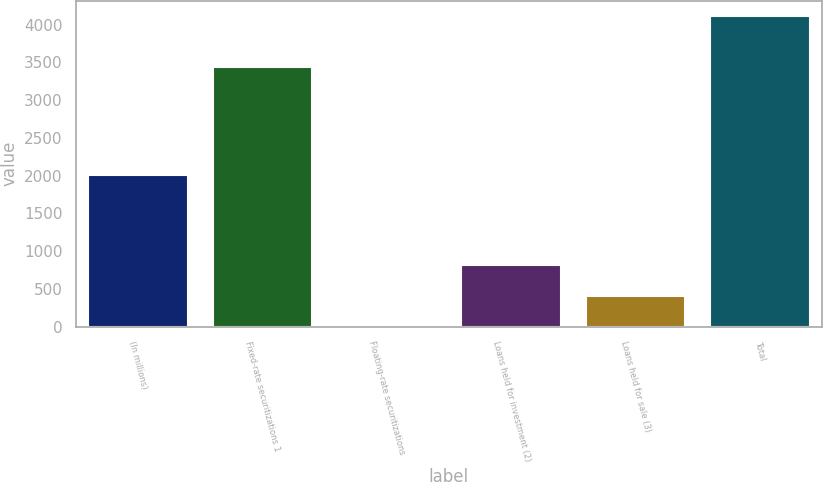<chart> <loc_0><loc_0><loc_500><loc_500><bar_chart><fcel>(In millions)<fcel>Fixed-rate securitizations 1<fcel>Floating-rate securitizations<fcel>Loans held for investment (2)<fcel>Loans held for sale (3)<fcel>Total<nl><fcel>2010<fcel>3432.9<fcel>0.8<fcel>823.18<fcel>411.99<fcel>4112.7<nl></chart> 